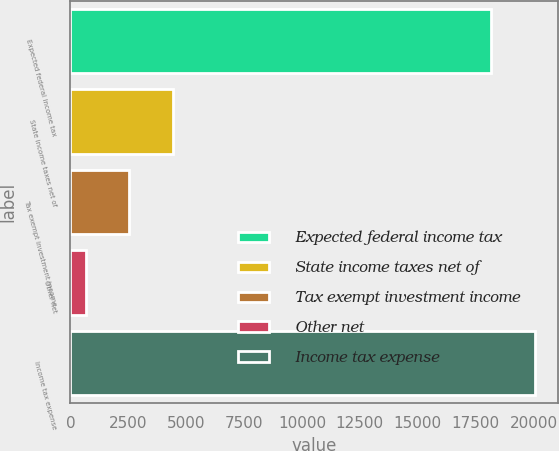Convert chart to OTSL. <chart><loc_0><loc_0><loc_500><loc_500><bar_chart><fcel>Expected federal income tax<fcel>State income taxes net of<fcel>Tax exempt investment income<fcel>Other net<fcel>Income tax expense<nl><fcel>18163<fcel>4424.8<fcel>2539.9<fcel>655<fcel>20047.9<nl></chart> 